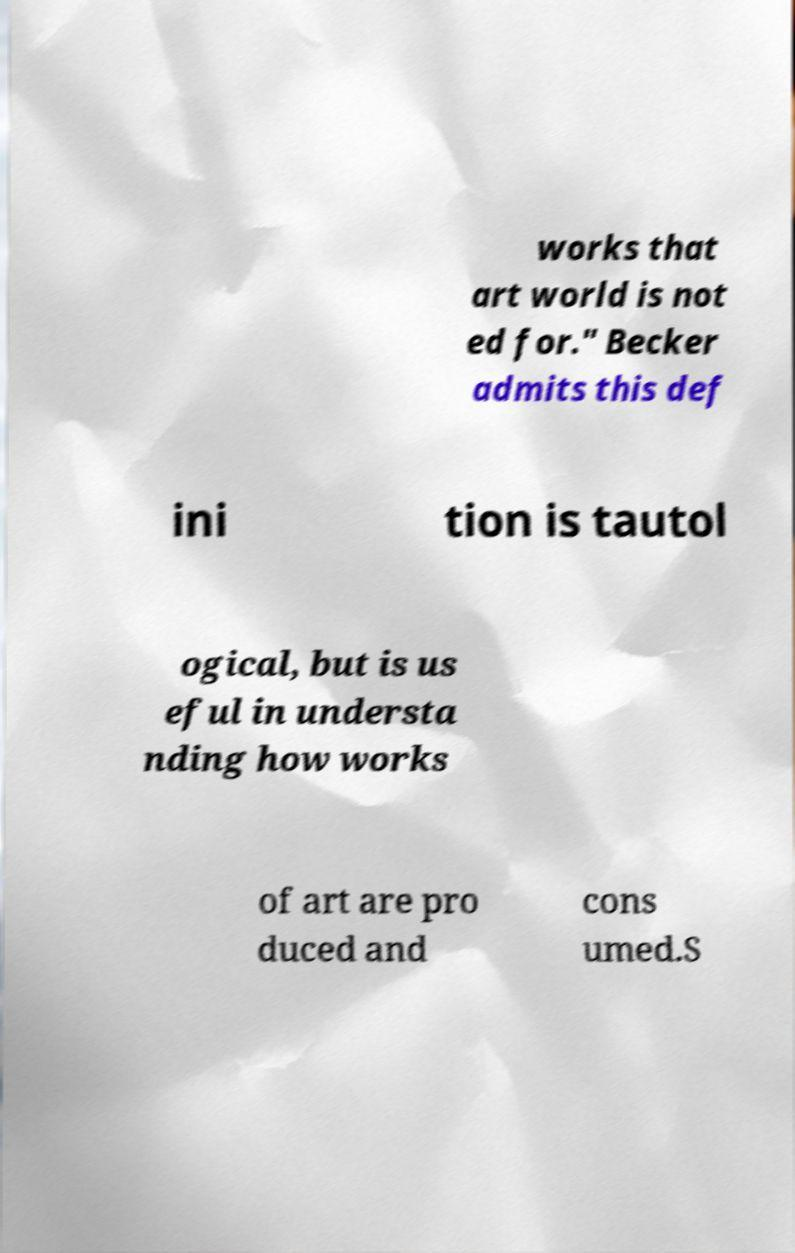For documentation purposes, I need the text within this image transcribed. Could you provide that? works that art world is not ed for." Becker admits this def ini tion is tautol ogical, but is us eful in understa nding how works of art are pro duced and cons umed.S 